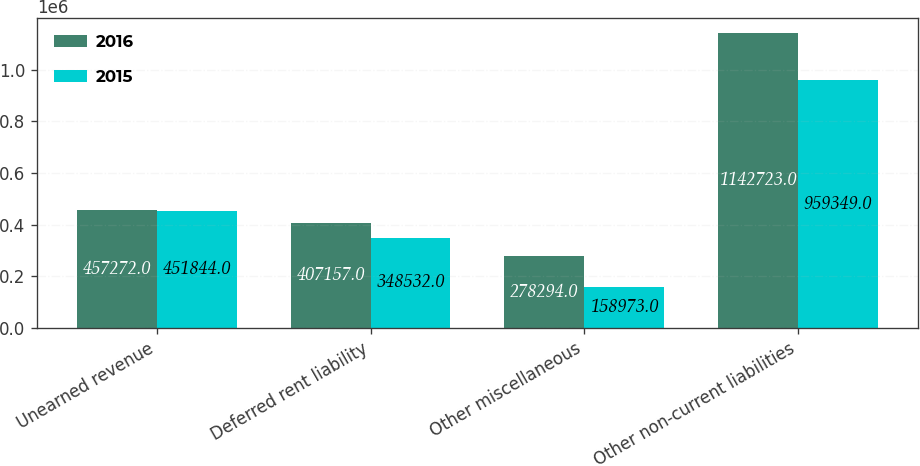Convert chart to OTSL. <chart><loc_0><loc_0><loc_500><loc_500><stacked_bar_chart><ecel><fcel>Unearned revenue<fcel>Deferred rent liability<fcel>Other miscellaneous<fcel>Other non-current liabilities<nl><fcel>2016<fcel>457272<fcel>407157<fcel>278294<fcel>1.14272e+06<nl><fcel>2015<fcel>451844<fcel>348532<fcel>158973<fcel>959349<nl></chart> 